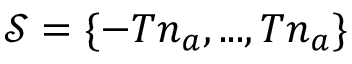Convert formula to latex. <formula><loc_0><loc_0><loc_500><loc_500>\mathcal { S } = \{ - T n _ { a } , \dots , T n _ { a } \}</formula> 